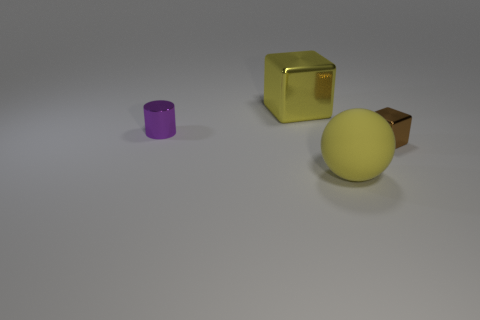What number of brown balls have the same size as the brown cube?
Keep it short and to the point. 0. The thing that is behind the big ball and to the right of the yellow metallic object is what color?
Offer a very short reply. Brown. Are there more cubes in front of the big yellow shiny object than small blue spheres?
Provide a succinct answer. Yes. Is there a cyan metal cylinder?
Provide a short and direct response. No. Do the sphere and the tiny cylinder have the same color?
Provide a short and direct response. No. What number of large objects are either blue rubber balls or metal cylinders?
Offer a very short reply. 0. Is there any other thing that has the same color as the big metal cube?
Provide a succinct answer. Yes. What is the shape of the big yellow thing that is the same material as the small brown thing?
Provide a short and direct response. Cube. What size is the block in front of the tiny purple cylinder?
Give a very brief answer. Small. The yellow metallic thing is what shape?
Provide a succinct answer. Cube. 